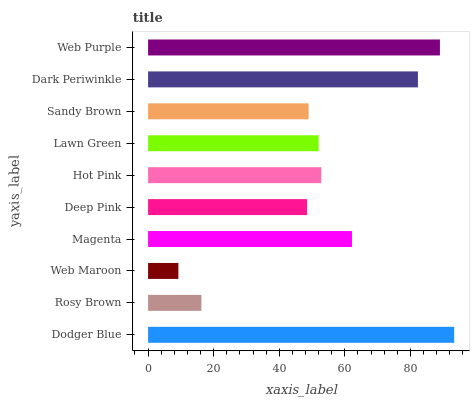Is Web Maroon the minimum?
Answer yes or no. Yes. Is Dodger Blue the maximum?
Answer yes or no. Yes. Is Rosy Brown the minimum?
Answer yes or no. No. Is Rosy Brown the maximum?
Answer yes or no. No. Is Dodger Blue greater than Rosy Brown?
Answer yes or no. Yes. Is Rosy Brown less than Dodger Blue?
Answer yes or no. Yes. Is Rosy Brown greater than Dodger Blue?
Answer yes or no. No. Is Dodger Blue less than Rosy Brown?
Answer yes or no. No. Is Hot Pink the high median?
Answer yes or no. Yes. Is Lawn Green the low median?
Answer yes or no. Yes. Is Deep Pink the high median?
Answer yes or no. No. Is Web Maroon the low median?
Answer yes or no. No. 